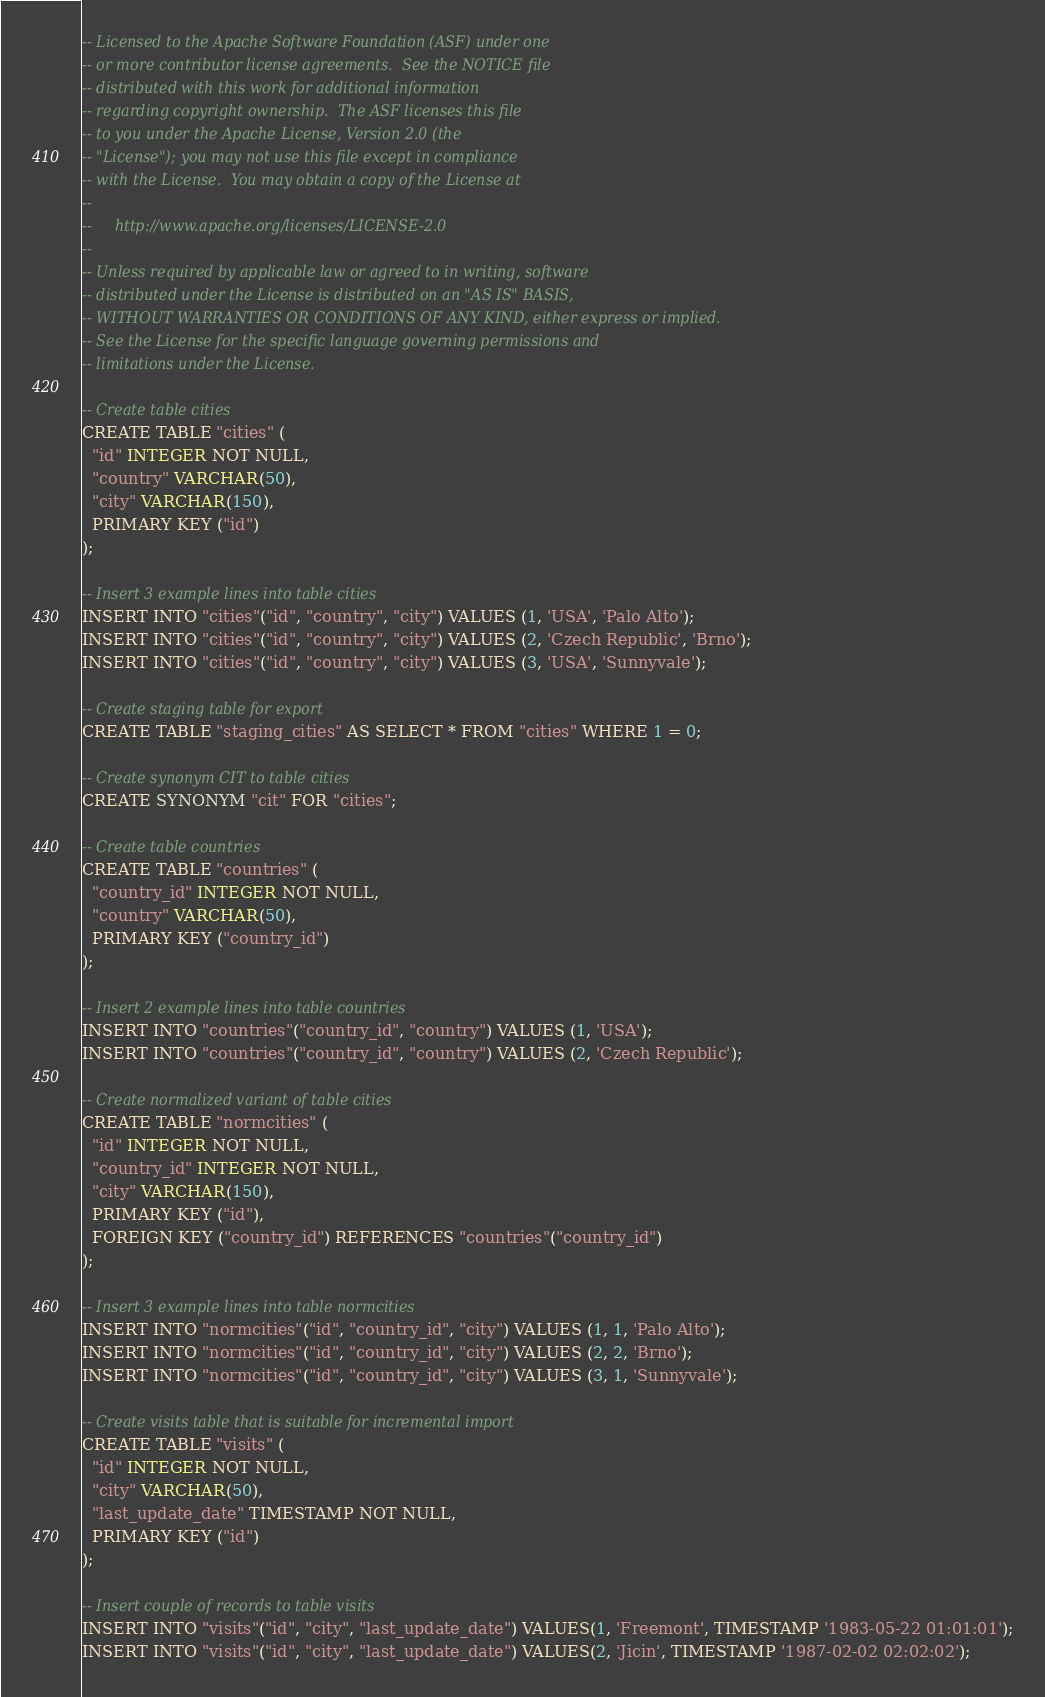Convert code to text. <code><loc_0><loc_0><loc_500><loc_500><_SQL_>-- Licensed to the Apache Software Foundation (ASF) under one
-- or more contributor license agreements.  See the NOTICE file
-- distributed with this work for additional information
-- regarding copyright ownership.  The ASF licenses this file
-- to you under the Apache License, Version 2.0 (the
-- "License"); you may not use this file except in compliance
-- with the License.  You may obtain a copy of the License at
--
--     http://www.apache.org/licenses/LICENSE-2.0
--
-- Unless required by applicable law or agreed to in writing, software
-- distributed under the License is distributed on an "AS IS" BASIS,
-- WITHOUT WARRANTIES OR CONDITIONS OF ANY KIND, either express or implied.
-- See the License for the specific language governing permissions and
-- limitations under the License.

-- Create table cities
CREATE TABLE "cities" (
  "id" INTEGER NOT NULL,
  "country" VARCHAR(50),
  "city" VARCHAR(150),
  PRIMARY KEY ("id")
);

-- Insert 3 example lines into table cities
INSERT INTO "cities"("id", "country", "city") VALUES (1, 'USA', 'Palo Alto');
INSERT INTO "cities"("id", "country", "city") VALUES (2, 'Czech Republic', 'Brno');
INSERT INTO "cities"("id", "country", "city") VALUES (3, 'USA', 'Sunnyvale');

-- Create staging table for export
CREATE TABLE "staging_cities" AS SELECT * FROM "cities" WHERE 1 = 0;

-- Create synonym CIT to table cities
CREATE SYNONYM "cit" FOR "cities";

-- Create table countries
CREATE TABLE "countries" (
  "country_id" INTEGER NOT NULL,
  "country" VARCHAR(50),
  PRIMARY KEY ("country_id")
);

-- Insert 2 example lines into table countries
INSERT INTO "countries"("country_id", "country") VALUES (1, 'USA');
INSERT INTO "countries"("country_id", "country") VALUES (2, 'Czech Republic');

-- Create normalized variant of table cities
CREATE TABLE "normcities" (
  "id" INTEGER NOT NULL,
  "country_id" INTEGER NOT NULL,
  "city" VARCHAR(150),
  PRIMARY KEY ("id"),
  FOREIGN KEY ("country_id") REFERENCES "countries"("country_id")
);

-- Insert 3 example lines into table normcities
INSERT INTO "normcities"("id", "country_id", "city") VALUES (1, 1, 'Palo Alto');
INSERT INTO "normcities"("id", "country_id", "city") VALUES (2, 2, 'Brno');
INSERT INTO "normcities"("id", "country_id", "city") VALUES (3, 1, 'Sunnyvale');

-- Create visits table that is suitable for incremental import
CREATE TABLE "visits" (
  "id" INTEGER NOT NULL,
  "city" VARCHAR(50),
  "last_update_date" TIMESTAMP NOT NULL,
  PRIMARY KEY ("id")
);

-- Insert couple of records to table visits
INSERT INTO "visits"("id", "city", "last_update_date") VALUES(1, 'Freemont', TIMESTAMP '1983-05-22 01:01:01');
INSERT INTO "visits"("id", "city", "last_update_date") VALUES(2, 'Jicin', TIMESTAMP '1987-02-02 02:02:02');
</code> 